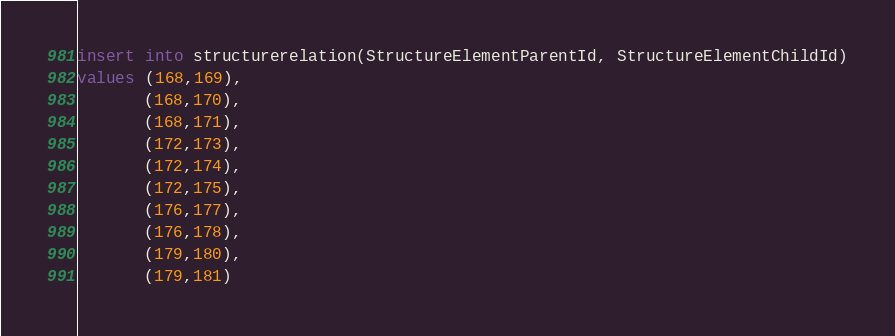Convert code to text. <code><loc_0><loc_0><loc_500><loc_500><_SQL_>insert into structurerelation(StructureElementParentId, StructureElementChildId)
values (168,169),
	   (168,170),
	   (168,171),
	   (172,173),
	   (172,174),
	   (172,175),
	   (176,177),
	   (176,178),
	   (179,180),
	   (179,181)</code> 